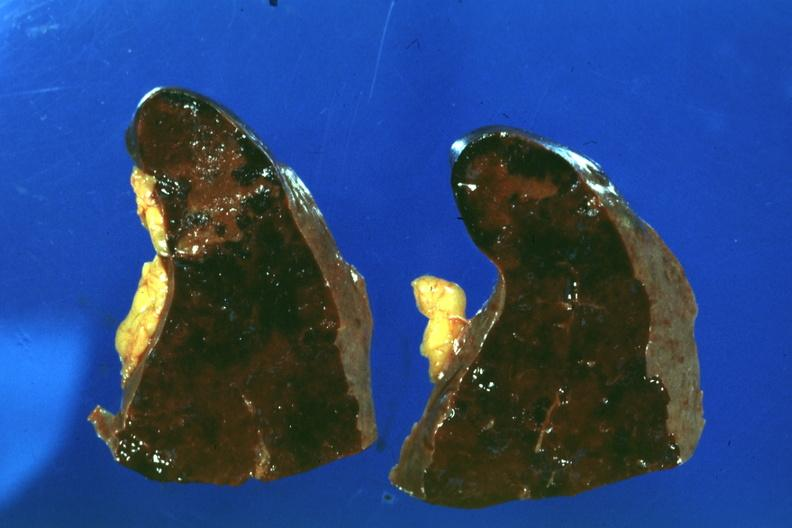s the unknown origin in mandible present?
Answer the question using a single word or phrase. No 